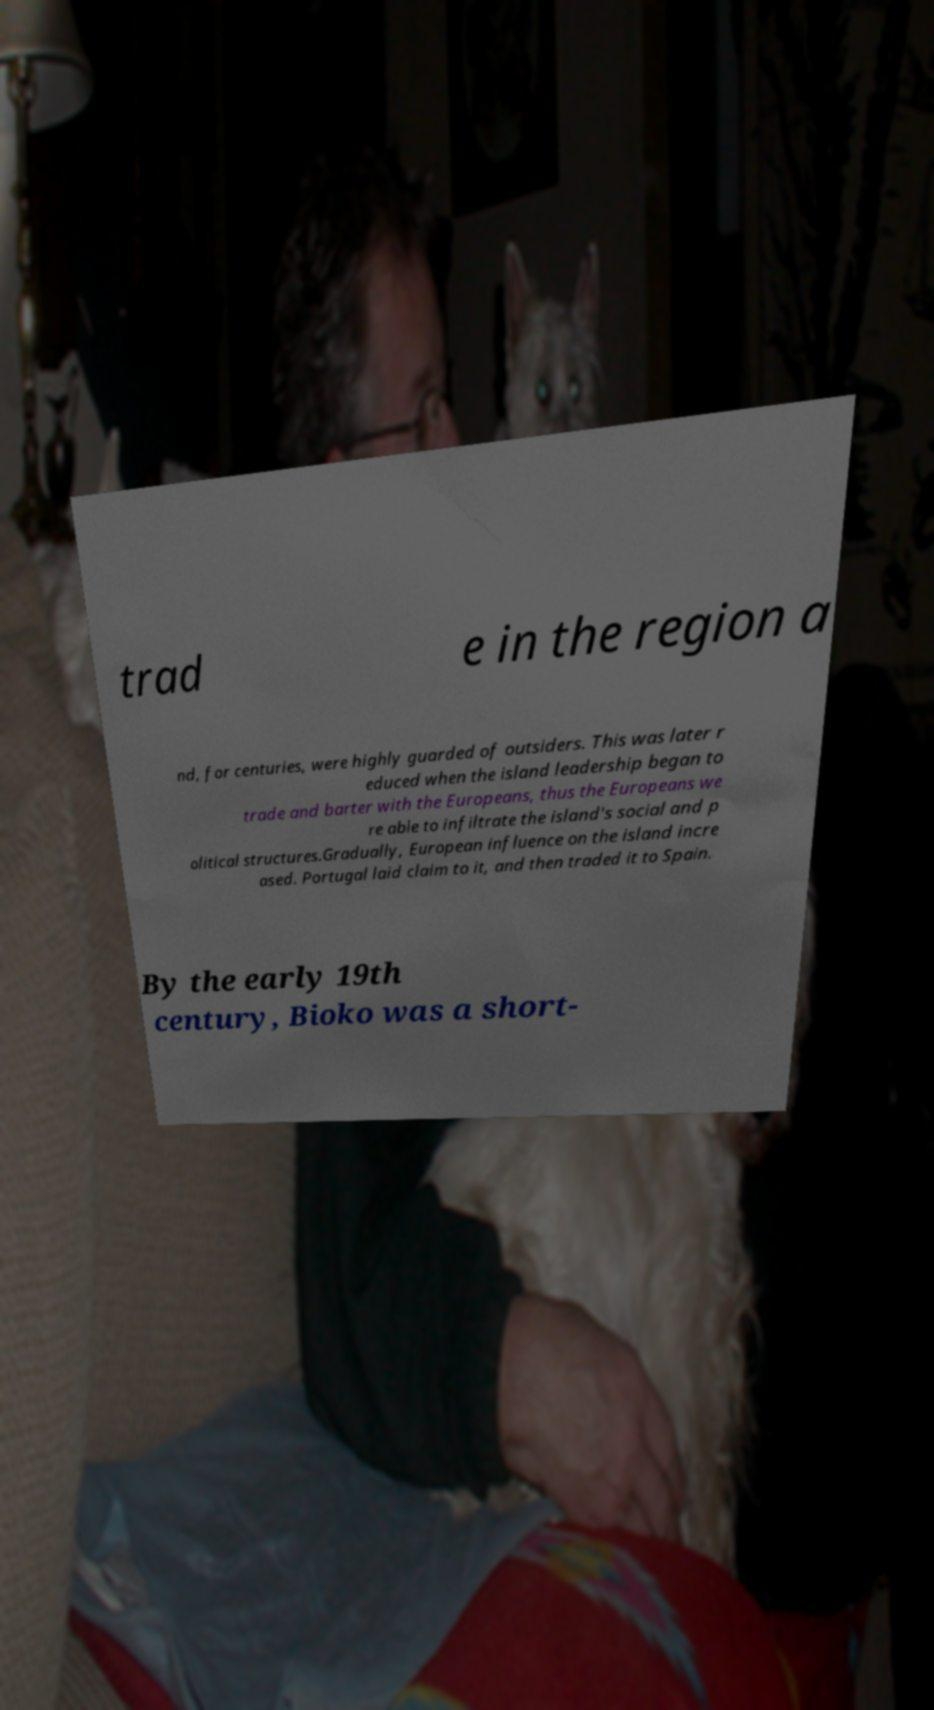Can you read and provide the text displayed in the image?This photo seems to have some interesting text. Can you extract and type it out for me? trad e in the region a nd, for centuries, were highly guarded of outsiders. This was later r educed when the island leadership began to trade and barter with the Europeans, thus the Europeans we re able to infiltrate the island's social and p olitical structures.Gradually, European influence on the island incre ased. Portugal laid claim to it, and then traded it to Spain. By the early 19th century, Bioko was a short- 